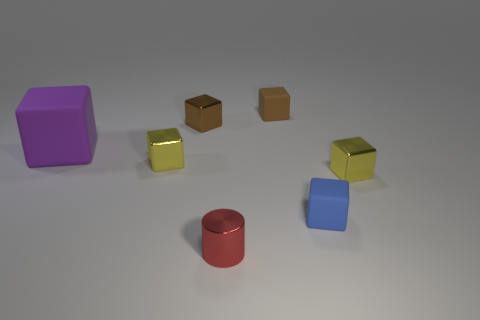Subtract all blue cubes. How many cubes are left? 5 Subtract all small brown matte cubes. How many cubes are left? 5 Subtract 1 blocks. How many blocks are left? 5 Subtract all red cubes. Subtract all blue balls. How many cubes are left? 6 Add 2 cyan metal things. How many objects exist? 9 Subtract all cylinders. How many objects are left? 6 Subtract 0 yellow spheres. How many objects are left? 7 Subtract all small blue blocks. Subtract all tiny rubber cubes. How many objects are left? 4 Add 6 cylinders. How many cylinders are left? 7 Add 6 large purple rubber spheres. How many large purple rubber spheres exist? 6 